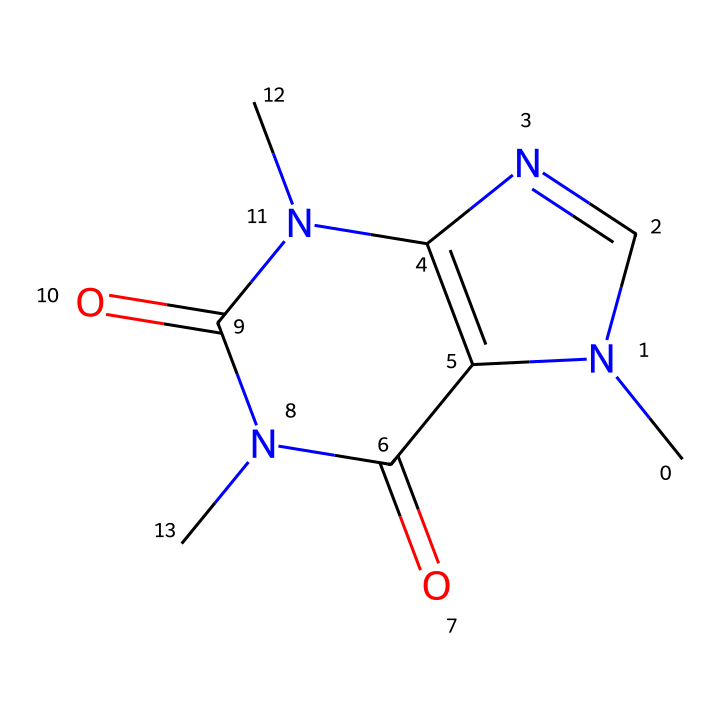What is the molecular formula of caffeine? To derive the molecular formula from the SMILES representation, you count the number of each type of atom. The SMILES shows carbon (C), hydrogen (H), nitrogen (N), and oxygen (O) atoms. After counting: 8 Carbons, 10 Hydrogens, 4 Nitrogens, and 2 Oxygens gives the formula C8H10N4O2.
Answer: C8H10N4O2 How many nitrogen atoms are present in caffeine? By examining the SMILES representation, the presence of 'N' indicates nitrogen atoms. Counting yields four nitrogen atoms in the structure.
Answer: 4 What type of functional groups are present in caffeine? Analyzing the SMILES shows the presence of carbonyl groups (C=O) and amine groups (N). The structure contains two carbonyls and nitrogen atoms bonding with carbon, indicating functional groups typical of amines and amides.
Answer: carbonyls and amines What is the primary role of caffeine in cognitive performance? Caffeine primarily acts as a stimulant in the brain by blocking adenosine receptors, which typically promote sleep and relaxation. This antagonism increases alertness and improves cognitive functions like attention and memory, especially in older adults.
Answer: stimulant How many rings are in the caffeine structure? Observing the cyclic nature of the SMILES indicates that caffeine has two interconnected rings composed of carbon and nitrogen. Therefore, we conclude that there are two rings in the molecular structure.
Answer: 2 What might the increased nitrogen presence in caffeine suggest about its properties? A higher number of nitrogen atoms in caffeine suggests an alkaloid nature, often associated with biological activity, such as affecting neurotransmitter systems. This can hint at its potential to improve cognitive abilities in older adults.
Answer: biological activity 